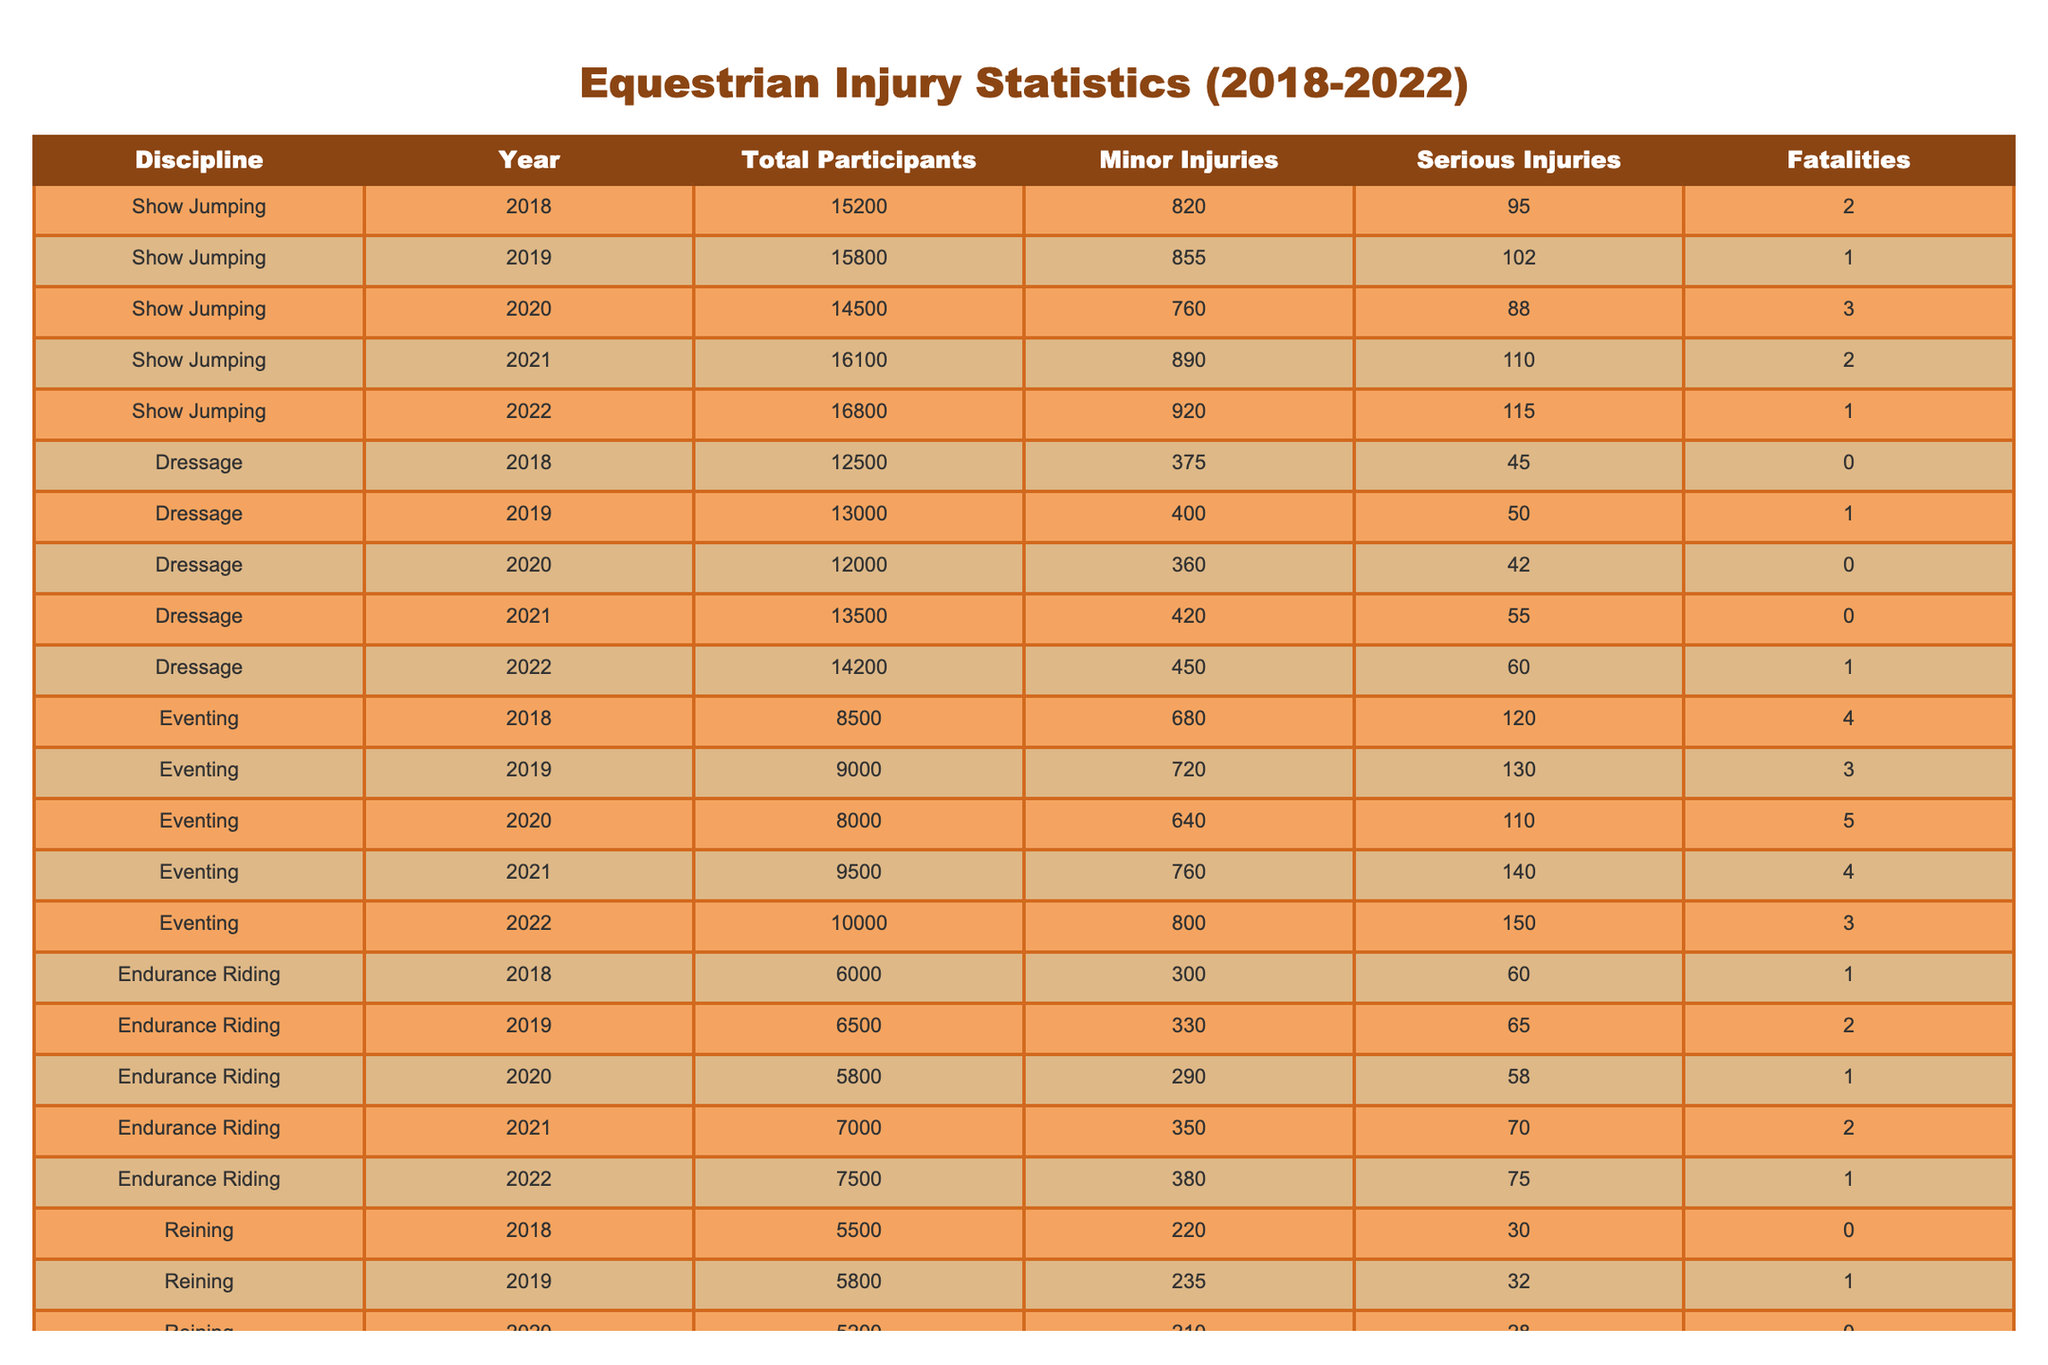What was the total number of fatalities in Eventing from 2018 to 2022? To find the total fatalities in Eventing, I will sum the fatalities for each year: 4 (2018) + 3 (2019) + 5 (2020) + 4 (2021) + 3 (2022) = 19.
Answer: 19 Which discipline had the highest number of serious injuries in 2021? I will check the serious injuries for each discipline in 2021: Show Jumping (110), Dressage (55), Eventing (140), Endurance Riding (70), Reining (35). Eventing had the highest with 140 serious injuries.
Answer: Eventing What was the average number of minor injuries across all disciplines in 2022? To calculate the average, I will sum the minor injuries for all disciplines in 2022: 920 (Show Jumping) + 450 (Dressage) + 800 (Eventing) + 380 (Endurance Riding) + 255 (Reining) = 2805. There are 5 disciplines, so the average is 2805 / 5 = 561.
Answer: 561 Did any discipline report no fatalities in 2022? I can check the fatalities for each discipline in 2022: Show Jumping (1), Dressage (1), Eventing (3), Endurance Riding (1), Reining (1). None had 0 fatalities, so the answer is no.
Answer: No What was the percentage increase in total participants in Show Jumping from 2018 to 2022? The total participants in 2018 were 15,200 and in 2022, it was 16,800. The increase is 16,800 - 15,200 = 1,600. To find the percentage increase: (1,600 / 15,200) * 100 = 10.53%.
Answer: 10.53% Which equestrian discipline had the lowest number of minor injuries in 2019? Looking at the minor injuries in 2019 for each discipline: Show Jumping (855), Dressage (400), Eventing (720), Endurance Riding (330), Reining (235). Reining had the lowest with 235 minor injuries.
Answer: Reining How many total serious injuries were recorded in Dressage from 2018 to 2022? I will sum the serious injuries in Dressage: 45 (2018) + 50 (2019) + 42 (2020) + 55 (2021) + 60 (2022) = 252.
Answer: 252 Which year had the highest number of fatalities in Endurance Riding, and how many were there? I check the fatalities for Endurance Riding: 1 (2018), 2 (2019), 1 (2020), 2 (2021), and 1 (2022). The highest was in 2019 with 2 fatalities.
Answer: 2019, 2 In which discipline did the number of minor injuries decrease from 2020 to 2021? I compare the minor injuries for each discipline: Show Jumping (760 in 2020 and 890 in 2021), Dressage (360 to 420), Eventing (640 to 760), Endurance Riding (290 to 350), Reining (210 to 240). All had an increase, so none decreased.
Answer: None How many serious injuries in total were recorded for Reining over the five years? I sum the serious injuries for Reining: 30 (2018) + 32 (2019) + 28 (2020) + 35 (2021) + 38 (2022) = 163.
Answer: 163 